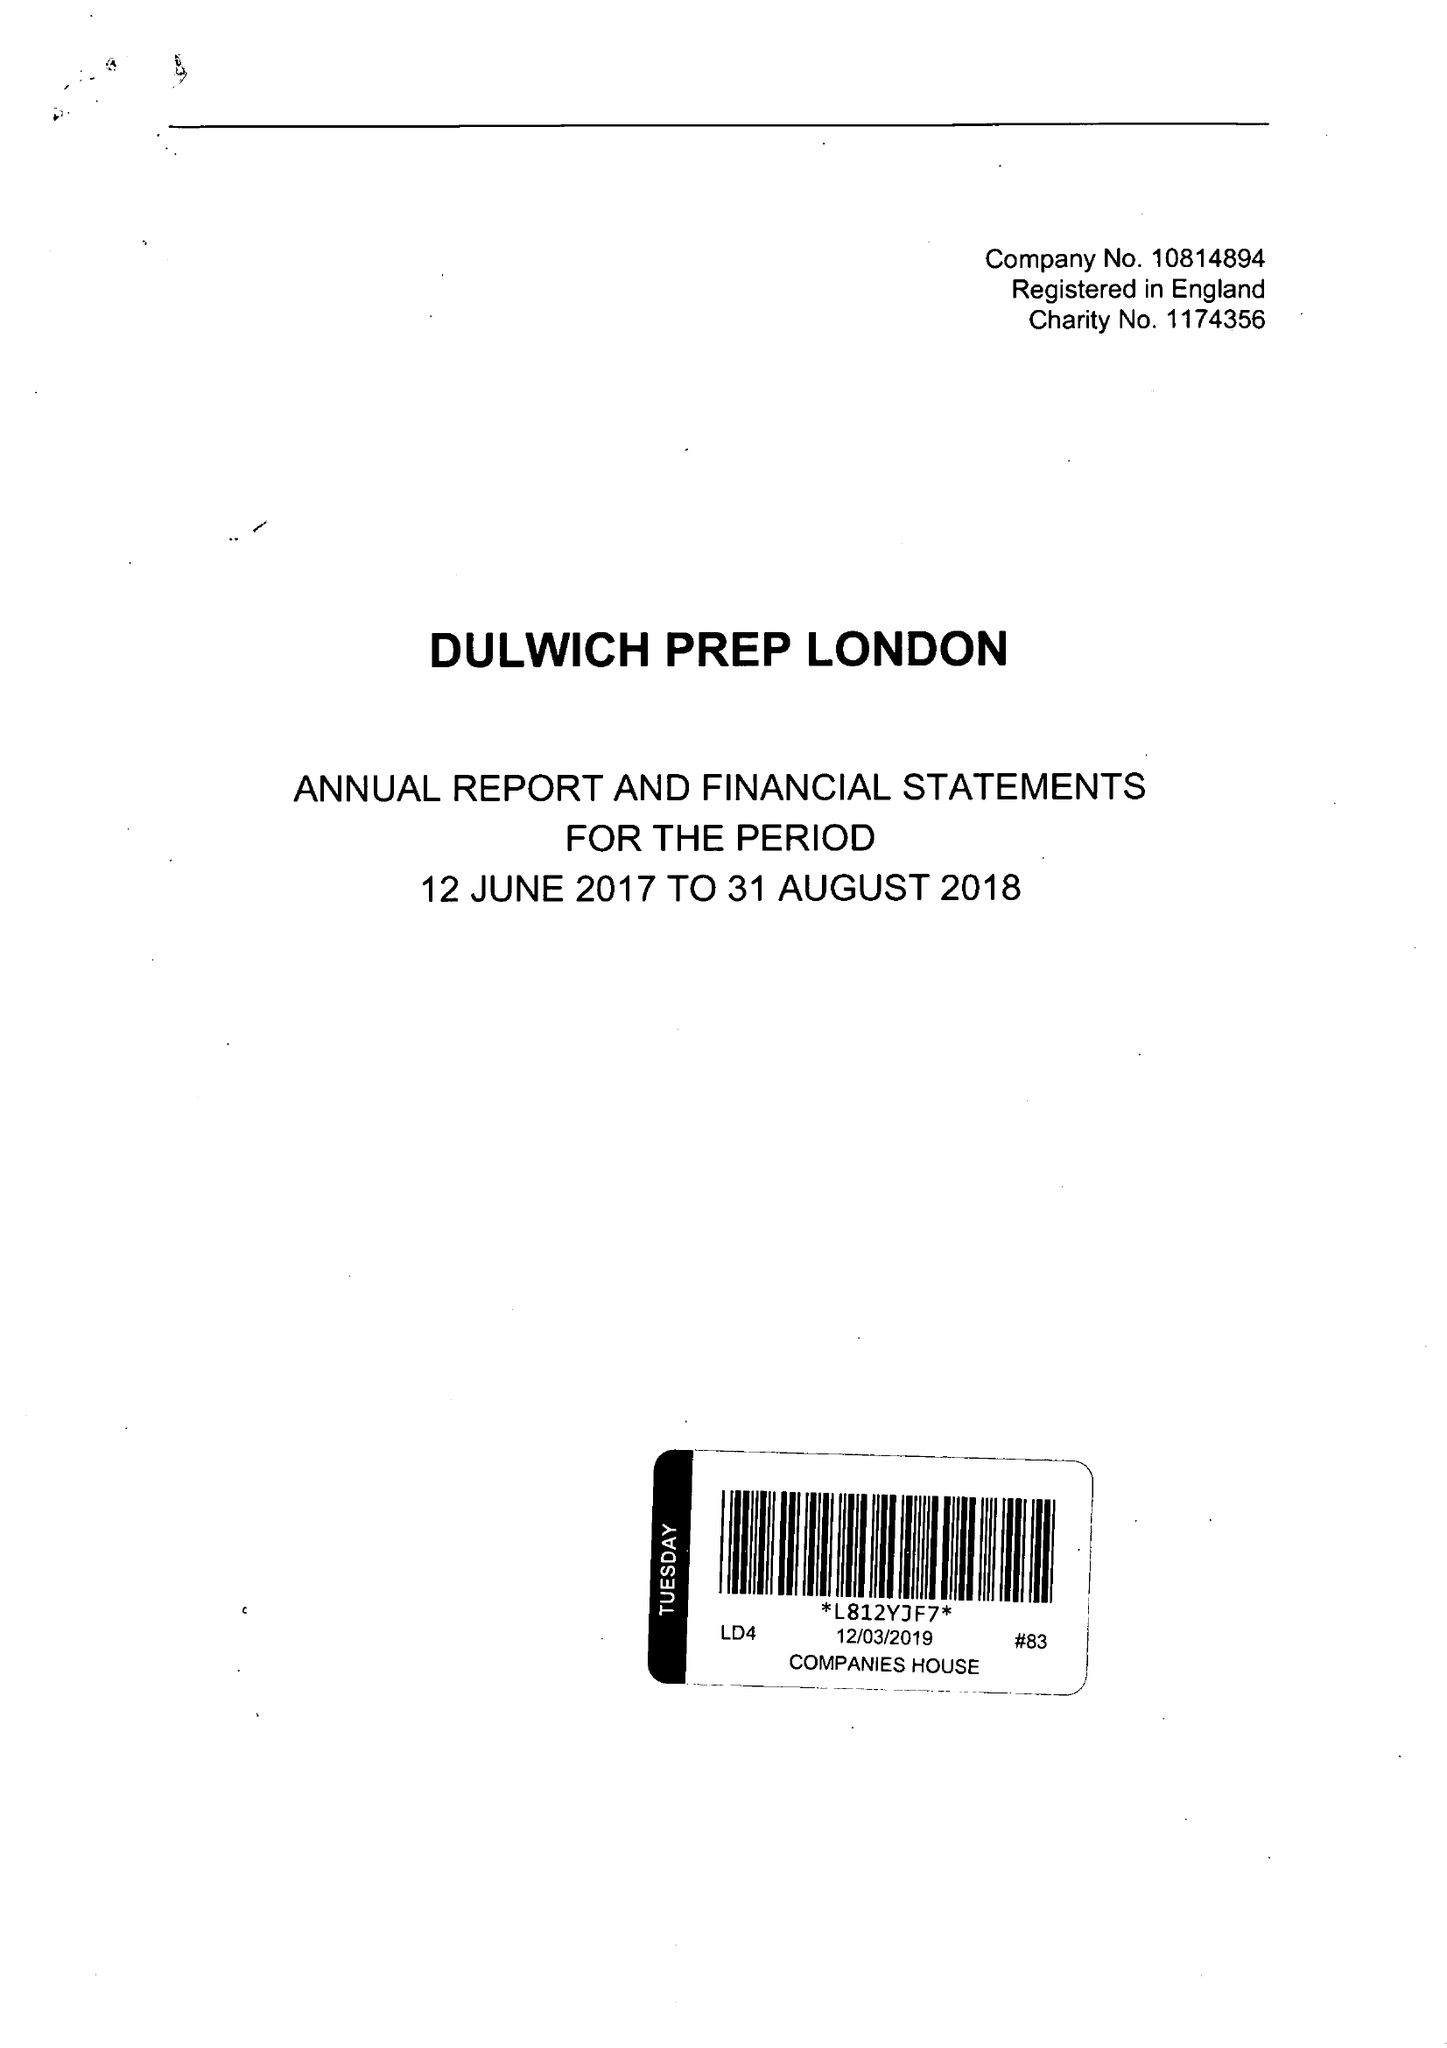What is the value for the charity_number?
Answer the question using a single word or phrase. 1174356 